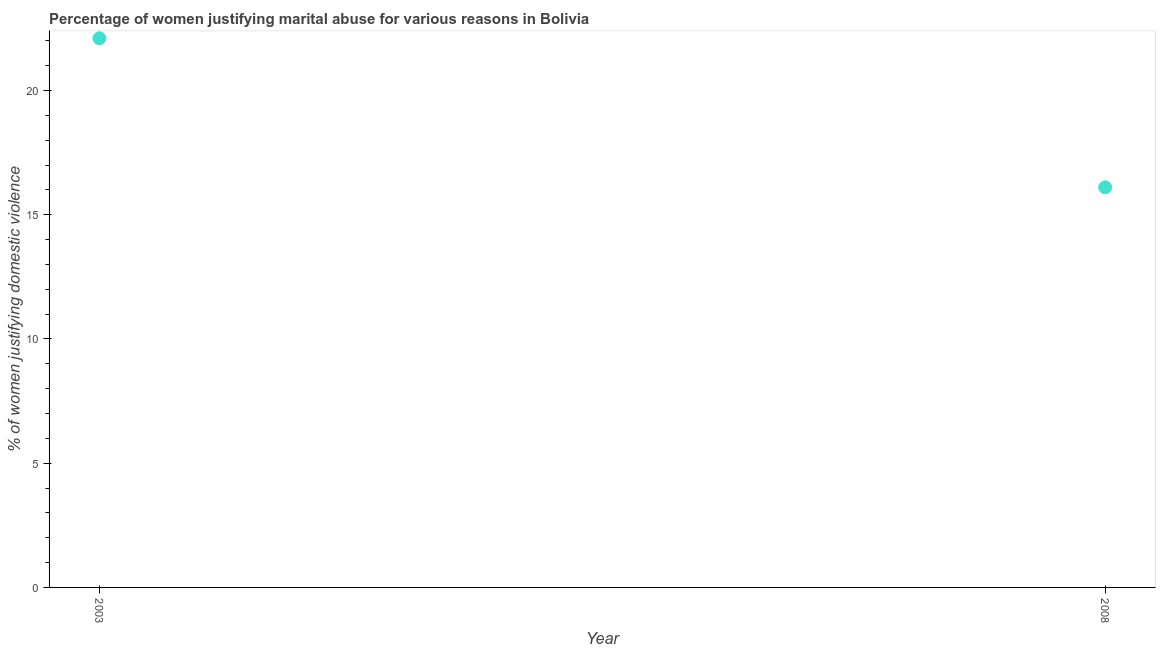Across all years, what is the maximum percentage of women justifying marital abuse?
Provide a short and direct response. 22.1. Across all years, what is the minimum percentage of women justifying marital abuse?
Provide a succinct answer. 16.1. In which year was the percentage of women justifying marital abuse maximum?
Your response must be concise. 2003. In which year was the percentage of women justifying marital abuse minimum?
Provide a short and direct response. 2008. What is the sum of the percentage of women justifying marital abuse?
Make the answer very short. 38.2. What is the difference between the percentage of women justifying marital abuse in 2003 and 2008?
Make the answer very short. 6. What is the average percentage of women justifying marital abuse per year?
Provide a short and direct response. 19.1. What is the ratio of the percentage of women justifying marital abuse in 2003 to that in 2008?
Offer a terse response. 1.37. In how many years, is the percentage of women justifying marital abuse greater than the average percentage of women justifying marital abuse taken over all years?
Offer a very short reply. 1. How many dotlines are there?
Provide a short and direct response. 1. How many years are there in the graph?
Your response must be concise. 2. What is the difference between two consecutive major ticks on the Y-axis?
Your answer should be compact. 5. Are the values on the major ticks of Y-axis written in scientific E-notation?
Your answer should be compact. No. Does the graph contain any zero values?
Provide a succinct answer. No. Does the graph contain grids?
Provide a succinct answer. No. What is the title of the graph?
Keep it short and to the point. Percentage of women justifying marital abuse for various reasons in Bolivia. What is the label or title of the Y-axis?
Provide a short and direct response. % of women justifying domestic violence. What is the % of women justifying domestic violence in 2003?
Ensure brevity in your answer.  22.1. What is the % of women justifying domestic violence in 2008?
Make the answer very short. 16.1. What is the difference between the % of women justifying domestic violence in 2003 and 2008?
Keep it short and to the point. 6. What is the ratio of the % of women justifying domestic violence in 2003 to that in 2008?
Offer a very short reply. 1.37. 